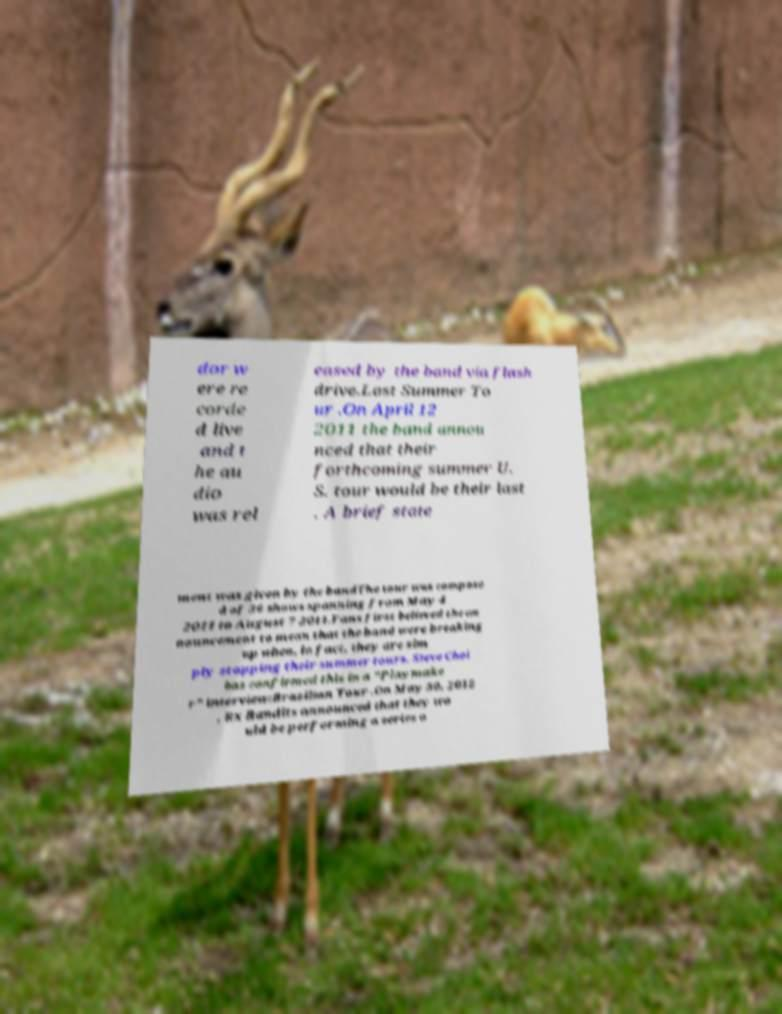I need the written content from this picture converted into text. Can you do that? dor w ere re corde d live and t he au dio was rel eased by the band via flash drive.Last Summer To ur .On April 12 2011 the band annou nced that their forthcoming summer U. S. tour would be their last . A brief state ment was given by the bandThe tour was compose d of 36 shows spanning from May 4 2011 to August 7 2011.Fans first believed the an nouncement to mean that the band were breaking up when, in fact, they are sim ply stopping their summer tours. Steve Choi has confirmed this in a "Playmake r" interview:Brazilian Tour .On May 30, 2012 , Rx Bandits announced that they wo uld be performing a series o 